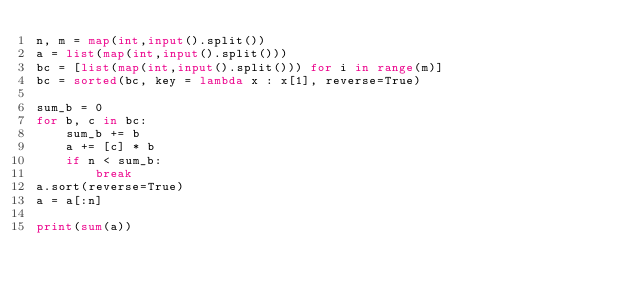<code> <loc_0><loc_0><loc_500><loc_500><_Python_>n, m = map(int,input().split())
a = list(map(int,input().split()))
bc = [list(map(int,input().split())) for i in range(m)]
bc = sorted(bc, key = lambda x : x[1], reverse=True)

sum_b = 0
for b, c in bc:
    sum_b += b
    a += [c] * b
    if n < sum_b:
        break
a.sort(reverse=True)
a = a[:n]

print(sum(a))</code> 